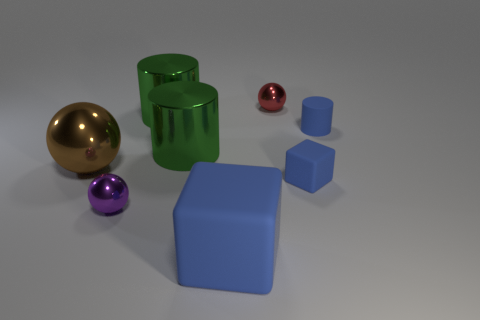How many matte objects have the same color as the tiny cylinder?
Give a very brief answer. 2. There is a shiny ball that is behind the brown ball; is its size the same as the blue rubber cube behind the small purple sphere?
Give a very brief answer. Yes. There is a red shiny sphere; does it have the same size as the cube that is to the left of the red ball?
Your response must be concise. No. The purple shiny sphere has what size?
Provide a short and direct response. Small. There is a cylinder that is made of the same material as the small blue cube; what is its color?
Make the answer very short. Blue. What number of small blue cylinders have the same material as the big blue block?
Give a very brief answer. 1. How many things are cyan shiny blocks or rubber objects to the right of the small rubber cube?
Offer a terse response. 1. Are the large object in front of the large brown shiny sphere and the tiny purple ball made of the same material?
Your answer should be very brief. No. What is the color of the sphere that is the same size as the red thing?
Provide a succinct answer. Purple. Is there a brown object that has the same shape as the big blue matte object?
Provide a succinct answer. No. 